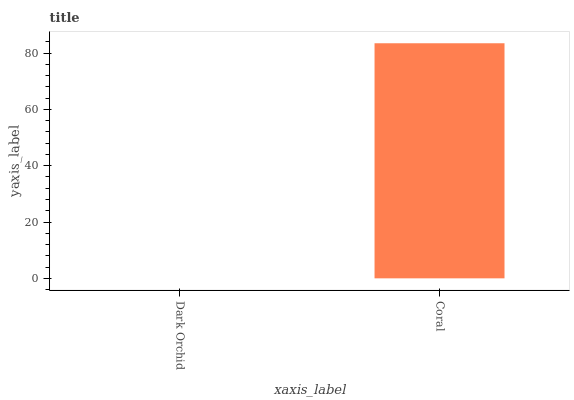Is Coral the minimum?
Answer yes or no. No. Is Coral greater than Dark Orchid?
Answer yes or no. Yes. Is Dark Orchid less than Coral?
Answer yes or no. Yes. Is Dark Orchid greater than Coral?
Answer yes or no. No. Is Coral less than Dark Orchid?
Answer yes or no. No. Is Coral the high median?
Answer yes or no. Yes. Is Dark Orchid the low median?
Answer yes or no. Yes. Is Dark Orchid the high median?
Answer yes or no. No. Is Coral the low median?
Answer yes or no. No. 